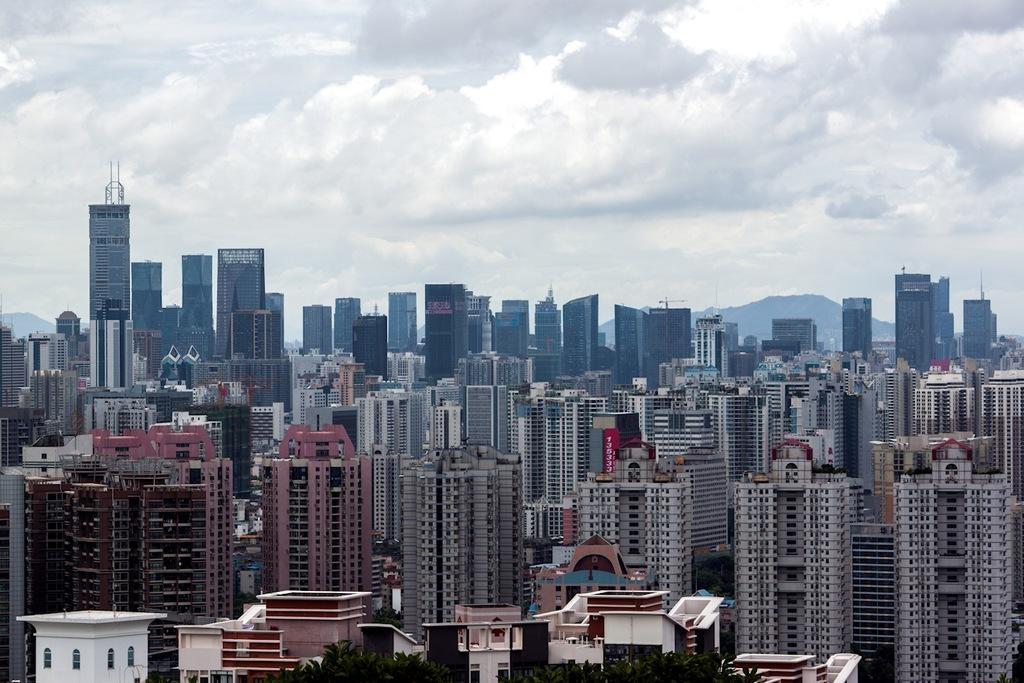What type of structures can be seen in the image? There are many buildings in the image. What is located at the bottom of the image? There are trees at the bottom of the image. What is visible behind the buildings? There are hills behind the buildings. What is visible at the top of the image? The sky is visible at the top of the image. What can be seen in the sky? Clouds are present in the sky. Where is the camera located in the image? There is no camera present in the image. Can you see the seashore in the image? The image does not show a seashore; it features buildings, trees, hills, and a sky with clouds. 